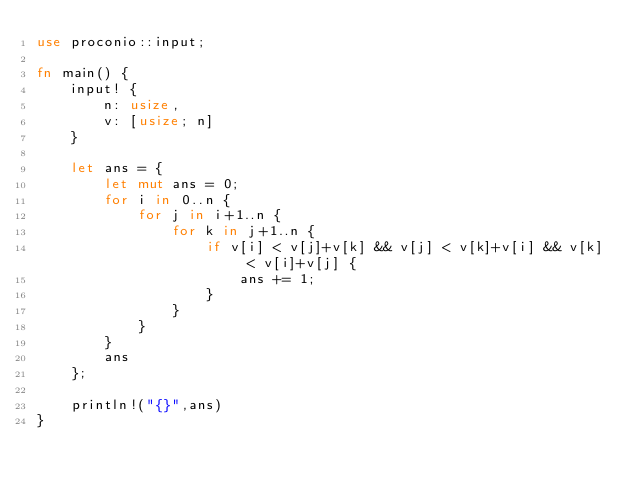Convert code to text. <code><loc_0><loc_0><loc_500><loc_500><_Rust_>use proconio::input;

fn main() {
    input! {
        n: usize,
        v: [usize; n]
    }

    let ans = {
        let mut ans = 0;
        for i in 0..n {
            for j in i+1..n {
                for k in j+1..n {
                    if v[i] < v[j]+v[k] && v[j] < v[k]+v[i] && v[k] < v[i]+v[j] {
                        ans += 1;
                    }
                }
            }
        }
        ans
    };

    println!("{}",ans)
}</code> 